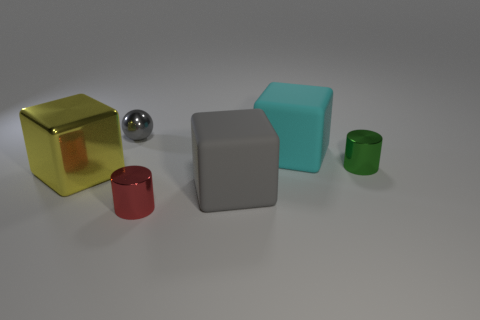What number of green objects are metal cubes or matte cubes?
Your answer should be compact. 0. There is a big cyan matte object; what number of gray blocks are behind it?
Provide a succinct answer. 0. Are there more balls than gray matte cylinders?
Provide a succinct answer. Yes. What is the shape of the matte object that is behind the large object that is on the left side of the small gray shiny thing?
Provide a succinct answer. Cube. Is the color of the small ball the same as the big shiny cube?
Make the answer very short. No. Is the number of gray matte objects behind the small green shiny cylinder greater than the number of large cyan balls?
Offer a terse response. No. What number of tiny green objects are in front of the cylinder right of the red cylinder?
Provide a short and direct response. 0. Does the small object that is left of the tiny red object have the same material as the small cylinder behind the yellow metallic block?
Your answer should be very brief. Yes. There is a object that is the same color as the small sphere; what material is it?
Your answer should be compact. Rubber. How many big things have the same shape as the small red metal thing?
Ensure brevity in your answer.  0. 